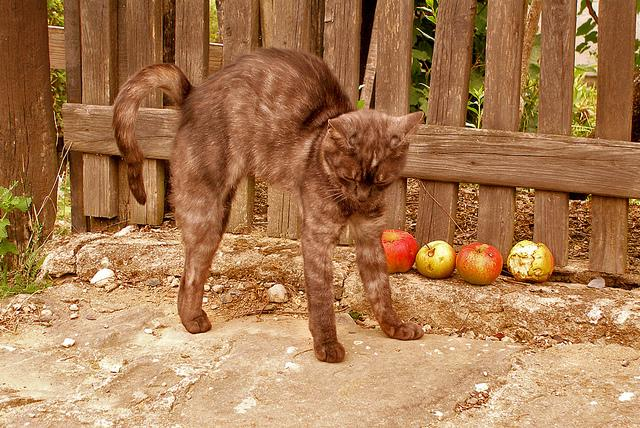What is the most popular type of apple?

Choices:
A) ladybug
B) honey crisp
C) red delicious
D) granny smith red delicious 